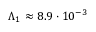Convert formula to latex. <formula><loc_0><loc_0><loc_500><loc_500>\Lambda _ { 1 } \approx 8 . 9 \cdot 1 0 ^ { - 3 }</formula> 